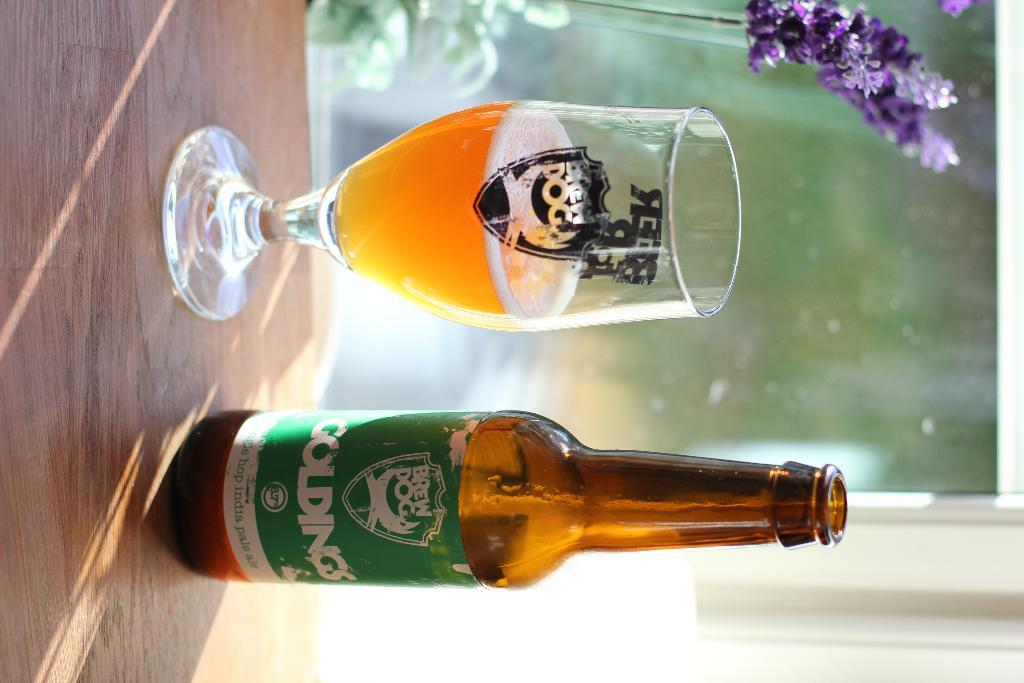<image>
Relay a brief, clear account of the picture shown. A Goldings beer sits next to a cup with beer. 